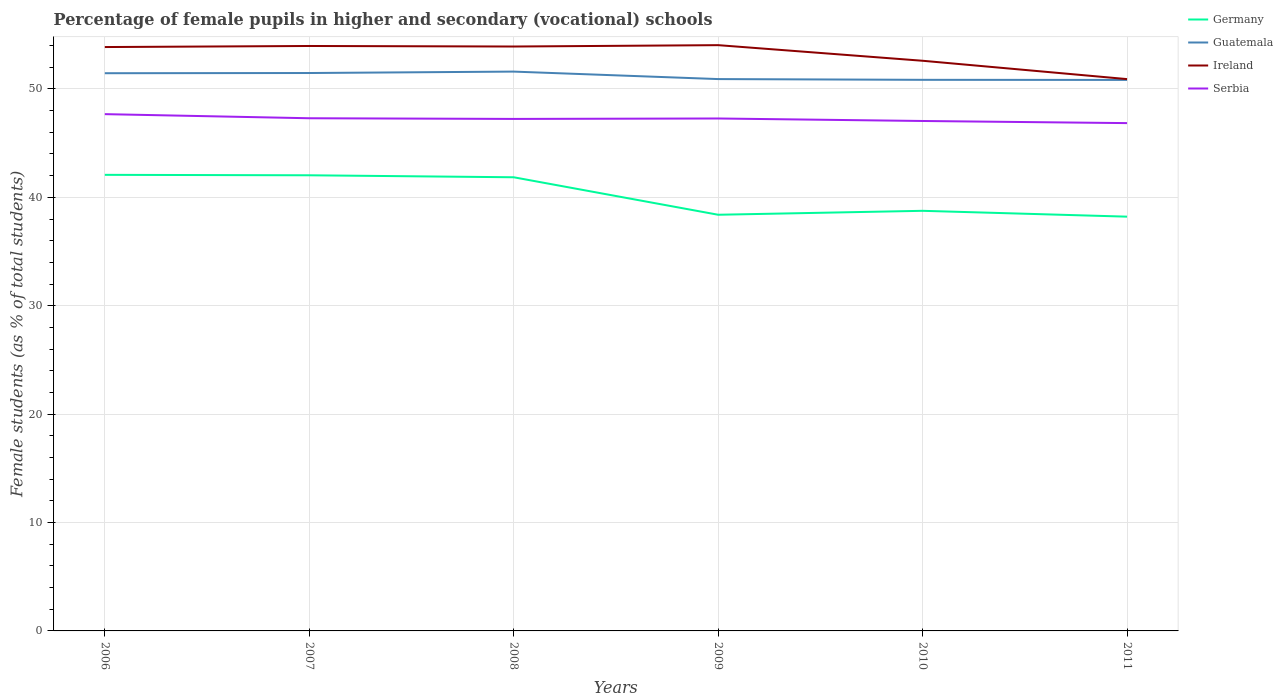Across all years, what is the maximum percentage of female pupils in higher and secondary schools in Serbia?
Your response must be concise. 46.85. In which year was the percentage of female pupils in higher and secondary schools in Ireland maximum?
Ensure brevity in your answer.  2011. What is the total percentage of female pupils in higher and secondary schools in Ireland in the graph?
Offer a terse response. 1.69. What is the difference between the highest and the second highest percentage of female pupils in higher and secondary schools in Serbia?
Offer a very short reply. 0.83. What is the difference between the highest and the lowest percentage of female pupils in higher and secondary schools in Serbia?
Provide a short and direct response. 4. Is the percentage of female pupils in higher and secondary schools in Ireland strictly greater than the percentage of female pupils in higher and secondary schools in Germany over the years?
Your answer should be compact. No. Does the graph contain any zero values?
Keep it short and to the point. No. How are the legend labels stacked?
Your answer should be compact. Vertical. What is the title of the graph?
Offer a very short reply. Percentage of female pupils in higher and secondary (vocational) schools. What is the label or title of the Y-axis?
Your answer should be compact. Female students (as % of total students). What is the Female students (as % of total students) in Germany in 2006?
Give a very brief answer. 42.08. What is the Female students (as % of total students) in Guatemala in 2006?
Make the answer very short. 51.45. What is the Female students (as % of total students) of Ireland in 2006?
Make the answer very short. 53.87. What is the Female students (as % of total students) of Serbia in 2006?
Your response must be concise. 47.68. What is the Female students (as % of total students) of Germany in 2007?
Provide a succinct answer. 42.04. What is the Female students (as % of total students) of Guatemala in 2007?
Provide a succinct answer. 51.47. What is the Female students (as % of total students) in Ireland in 2007?
Offer a very short reply. 53.97. What is the Female students (as % of total students) of Serbia in 2007?
Provide a succinct answer. 47.3. What is the Female students (as % of total students) in Germany in 2008?
Keep it short and to the point. 41.85. What is the Female students (as % of total students) of Guatemala in 2008?
Offer a terse response. 51.6. What is the Female students (as % of total students) of Ireland in 2008?
Make the answer very short. 53.92. What is the Female students (as % of total students) of Serbia in 2008?
Make the answer very short. 47.24. What is the Female students (as % of total students) of Germany in 2009?
Provide a short and direct response. 38.39. What is the Female students (as % of total students) in Guatemala in 2009?
Keep it short and to the point. 50.91. What is the Female students (as % of total students) in Ireland in 2009?
Give a very brief answer. 54.04. What is the Female students (as % of total students) of Serbia in 2009?
Ensure brevity in your answer.  47.28. What is the Female students (as % of total students) in Germany in 2010?
Provide a short and direct response. 38.76. What is the Female students (as % of total students) in Guatemala in 2010?
Provide a short and direct response. 50.84. What is the Female students (as % of total students) in Ireland in 2010?
Give a very brief answer. 52.6. What is the Female students (as % of total students) of Serbia in 2010?
Your answer should be very brief. 47.05. What is the Female students (as % of total students) of Germany in 2011?
Your response must be concise. 38.22. What is the Female students (as % of total students) of Guatemala in 2011?
Ensure brevity in your answer.  50.83. What is the Female students (as % of total students) of Ireland in 2011?
Offer a terse response. 50.91. What is the Female students (as % of total students) in Serbia in 2011?
Offer a very short reply. 46.85. Across all years, what is the maximum Female students (as % of total students) of Germany?
Offer a very short reply. 42.08. Across all years, what is the maximum Female students (as % of total students) in Guatemala?
Make the answer very short. 51.6. Across all years, what is the maximum Female students (as % of total students) in Ireland?
Provide a succinct answer. 54.04. Across all years, what is the maximum Female students (as % of total students) of Serbia?
Provide a succinct answer. 47.68. Across all years, what is the minimum Female students (as % of total students) in Germany?
Your answer should be compact. 38.22. Across all years, what is the minimum Female students (as % of total students) in Guatemala?
Make the answer very short. 50.83. Across all years, what is the minimum Female students (as % of total students) of Ireland?
Give a very brief answer. 50.91. Across all years, what is the minimum Female students (as % of total students) of Serbia?
Give a very brief answer. 46.85. What is the total Female students (as % of total students) in Germany in the graph?
Give a very brief answer. 241.34. What is the total Female students (as % of total students) of Guatemala in the graph?
Provide a succinct answer. 307.11. What is the total Female students (as % of total students) of Ireland in the graph?
Your answer should be very brief. 319.3. What is the total Female students (as % of total students) in Serbia in the graph?
Keep it short and to the point. 283.38. What is the difference between the Female students (as % of total students) of Germany in 2006 and that in 2007?
Keep it short and to the point. 0.04. What is the difference between the Female students (as % of total students) in Guatemala in 2006 and that in 2007?
Keep it short and to the point. -0.02. What is the difference between the Female students (as % of total students) in Ireland in 2006 and that in 2007?
Your response must be concise. -0.1. What is the difference between the Female students (as % of total students) in Serbia in 2006 and that in 2007?
Offer a terse response. 0.38. What is the difference between the Female students (as % of total students) of Germany in 2006 and that in 2008?
Your answer should be compact. 0.22. What is the difference between the Female students (as % of total students) of Guatemala in 2006 and that in 2008?
Your answer should be very brief. -0.15. What is the difference between the Female students (as % of total students) of Ireland in 2006 and that in 2008?
Your answer should be compact. -0.05. What is the difference between the Female students (as % of total students) of Serbia in 2006 and that in 2008?
Provide a short and direct response. 0.44. What is the difference between the Female students (as % of total students) in Germany in 2006 and that in 2009?
Ensure brevity in your answer.  3.68. What is the difference between the Female students (as % of total students) in Guatemala in 2006 and that in 2009?
Your answer should be compact. 0.54. What is the difference between the Female students (as % of total students) in Ireland in 2006 and that in 2009?
Provide a succinct answer. -0.17. What is the difference between the Female students (as % of total students) of Serbia in 2006 and that in 2009?
Provide a succinct answer. 0.4. What is the difference between the Female students (as % of total students) in Germany in 2006 and that in 2010?
Offer a very short reply. 3.32. What is the difference between the Female students (as % of total students) in Guatemala in 2006 and that in 2010?
Make the answer very short. 0.61. What is the difference between the Female students (as % of total students) in Ireland in 2006 and that in 2010?
Ensure brevity in your answer.  1.27. What is the difference between the Female students (as % of total students) of Serbia in 2006 and that in 2010?
Provide a succinct answer. 0.63. What is the difference between the Female students (as % of total students) in Germany in 2006 and that in 2011?
Provide a succinct answer. 3.86. What is the difference between the Female students (as % of total students) in Guatemala in 2006 and that in 2011?
Offer a very short reply. 0.62. What is the difference between the Female students (as % of total students) of Ireland in 2006 and that in 2011?
Keep it short and to the point. 2.96. What is the difference between the Female students (as % of total students) of Serbia in 2006 and that in 2011?
Offer a terse response. 0.83. What is the difference between the Female students (as % of total students) of Germany in 2007 and that in 2008?
Offer a very short reply. 0.18. What is the difference between the Female students (as % of total students) of Guatemala in 2007 and that in 2008?
Give a very brief answer. -0.13. What is the difference between the Female students (as % of total students) in Ireland in 2007 and that in 2008?
Ensure brevity in your answer.  0.05. What is the difference between the Female students (as % of total students) of Serbia in 2007 and that in 2008?
Keep it short and to the point. 0.06. What is the difference between the Female students (as % of total students) of Germany in 2007 and that in 2009?
Provide a short and direct response. 3.64. What is the difference between the Female students (as % of total students) of Guatemala in 2007 and that in 2009?
Provide a short and direct response. 0.56. What is the difference between the Female students (as % of total students) in Ireland in 2007 and that in 2009?
Give a very brief answer. -0.08. What is the difference between the Female students (as % of total students) in Serbia in 2007 and that in 2009?
Your response must be concise. 0.02. What is the difference between the Female students (as % of total students) of Germany in 2007 and that in 2010?
Give a very brief answer. 3.28. What is the difference between the Female students (as % of total students) of Guatemala in 2007 and that in 2010?
Give a very brief answer. 0.63. What is the difference between the Female students (as % of total students) of Ireland in 2007 and that in 2010?
Provide a short and direct response. 1.36. What is the difference between the Female students (as % of total students) of Serbia in 2007 and that in 2010?
Provide a succinct answer. 0.25. What is the difference between the Female students (as % of total students) in Germany in 2007 and that in 2011?
Your answer should be compact. 3.82. What is the difference between the Female students (as % of total students) in Guatemala in 2007 and that in 2011?
Offer a terse response. 0.64. What is the difference between the Female students (as % of total students) of Ireland in 2007 and that in 2011?
Offer a terse response. 3.06. What is the difference between the Female students (as % of total students) of Serbia in 2007 and that in 2011?
Ensure brevity in your answer.  0.45. What is the difference between the Female students (as % of total students) in Germany in 2008 and that in 2009?
Your response must be concise. 3.46. What is the difference between the Female students (as % of total students) in Guatemala in 2008 and that in 2009?
Offer a terse response. 0.69. What is the difference between the Female students (as % of total students) of Ireland in 2008 and that in 2009?
Keep it short and to the point. -0.13. What is the difference between the Female students (as % of total students) in Serbia in 2008 and that in 2009?
Your response must be concise. -0.04. What is the difference between the Female students (as % of total students) in Germany in 2008 and that in 2010?
Give a very brief answer. 3.09. What is the difference between the Female students (as % of total students) in Guatemala in 2008 and that in 2010?
Provide a succinct answer. 0.76. What is the difference between the Female students (as % of total students) in Ireland in 2008 and that in 2010?
Offer a terse response. 1.31. What is the difference between the Female students (as % of total students) in Serbia in 2008 and that in 2010?
Provide a succinct answer. 0.19. What is the difference between the Female students (as % of total students) of Germany in 2008 and that in 2011?
Provide a short and direct response. 3.63. What is the difference between the Female students (as % of total students) of Guatemala in 2008 and that in 2011?
Make the answer very short. 0.77. What is the difference between the Female students (as % of total students) of Ireland in 2008 and that in 2011?
Provide a succinct answer. 3.01. What is the difference between the Female students (as % of total students) of Serbia in 2008 and that in 2011?
Offer a terse response. 0.39. What is the difference between the Female students (as % of total students) of Germany in 2009 and that in 2010?
Your response must be concise. -0.36. What is the difference between the Female students (as % of total students) in Guatemala in 2009 and that in 2010?
Offer a terse response. 0.07. What is the difference between the Female students (as % of total students) of Ireland in 2009 and that in 2010?
Make the answer very short. 1.44. What is the difference between the Female students (as % of total students) in Serbia in 2009 and that in 2010?
Offer a terse response. 0.23. What is the difference between the Female students (as % of total students) of Germany in 2009 and that in 2011?
Keep it short and to the point. 0.17. What is the difference between the Female students (as % of total students) of Guatemala in 2009 and that in 2011?
Provide a succinct answer. 0.08. What is the difference between the Female students (as % of total students) in Ireland in 2009 and that in 2011?
Give a very brief answer. 3.13. What is the difference between the Female students (as % of total students) of Serbia in 2009 and that in 2011?
Your response must be concise. 0.43. What is the difference between the Female students (as % of total students) in Germany in 2010 and that in 2011?
Keep it short and to the point. 0.54. What is the difference between the Female students (as % of total students) of Guatemala in 2010 and that in 2011?
Make the answer very short. 0.01. What is the difference between the Female students (as % of total students) of Ireland in 2010 and that in 2011?
Your answer should be compact. 1.69. What is the difference between the Female students (as % of total students) in Serbia in 2010 and that in 2011?
Your response must be concise. 0.2. What is the difference between the Female students (as % of total students) in Germany in 2006 and the Female students (as % of total students) in Guatemala in 2007?
Your response must be concise. -9.39. What is the difference between the Female students (as % of total students) in Germany in 2006 and the Female students (as % of total students) in Ireland in 2007?
Make the answer very short. -11.89. What is the difference between the Female students (as % of total students) in Germany in 2006 and the Female students (as % of total students) in Serbia in 2007?
Your response must be concise. -5.22. What is the difference between the Female students (as % of total students) in Guatemala in 2006 and the Female students (as % of total students) in Ireland in 2007?
Offer a very short reply. -2.51. What is the difference between the Female students (as % of total students) in Guatemala in 2006 and the Female students (as % of total students) in Serbia in 2007?
Your answer should be compact. 4.15. What is the difference between the Female students (as % of total students) of Ireland in 2006 and the Female students (as % of total students) of Serbia in 2007?
Offer a terse response. 6.57. What is the difference between the Female students (as % of total students) of Germany in 2006 and the Female students (as % of total students) of Guatemala in 2008?
Ensure brevity in your answer.  -9.52. What is the difference between the Female students (as % of total students) of Germany in 2006 and the Female students (as % of total students) of Ireland in 2008?
Your response must be concise. -11.84. What is the difference between the Female students (as % of total students) in Germany in 2006 and the Female students (as % of total students) in Serbia in 2008?
Offer a terse response. -5.16. What is the difference between the Female students (as % of total students) in Guatemala in 2006 and the Female students (as % of total students) in Ireland in 2008?
Provide a short and direct response. -2.46. What is the difference between the Female students (as % of total students) of Guatemala in 2006 and the Female students (as % of total students) of Serbia in 2008?
Offer a terse response. 4.22. What is the difference between the Female students (as % of total students) of Ireland in 2006 and the Female students (as % of total students) of Serbia in 2008?
Ensure brevity in your answer.  6.63. What is the difference between the Female students (as % of total students) in Germany in 2006 and the Female students (as % of total students) in Guatemala in 2009?
Offer a terse response. -8.83. What is the difference between the Female students (as % of total students) of Germany in 2006 and the Female students (as % of total students) of Ireland in 2009?
Your answer should be very brief. -11.96. What is the difference between the Female students (as % of total students) of Germany in 2006 and the Female students (as % of total students) of Serbia in 2009?
Give a very brief answer. -5.2. What is the difference between the Female students (as % of total students) of Guatemala in 2006 and the Female students (as % of total students) of Ireland in 2009?
Your response must be concise. -2.59. What is the difference between the Female students (as % of total students) of Guatemala in 2006 and the Female students (as % of total students) of Serbia in 2009?
Ensure brevity in your answer.  4.18. What is the difference between the Female students (as % of total students) of Ireland in 2006 and the Female students (as % of total students) of Serbia in 2009?
Ensure brevity in your answer.  6.59. What is the difference between the Female students (as % of total students) of Germany in 2006 and the Female students (as % of total students) of Guatemala in 2010?
Keep it short and to the point. -8.77. What is the difference between the Female students (as % of total students) in Germany in 2006 and the Female students (as % of total students) in Ireland in 2010?
Offer a terse response. -10.52. What is the difference between the Female students (as % of total students) of Germany in 2006 and the Female students (as % of total students) of Serbia in 2010?
Your response must be concise. -4.97. What is the difference between the Female students (as % of total students) of Guatemala in 2006 and the Female students (as % of total students) of Ireland in 2010?
Offer a very short reply. -1.15. What is the difference between the Female students (as % of total students) in Guatemala in 2006 and the Female students (as % of total students) in Serbia in 2010?
Give a very brief answer. 4.41. What is the difference between the Female students (as % of total students) of Ireland in 2006 and the Female students (as % of total students) of Serbia in 2010?
Keep it short and to the point. 6.82. What is the difference between the Female students (as % of total students) of Germany in 2006 and the Female students (as % of total students) of Guatemala in 2011?
Keep it short and to the point. -8.76. What is the difference between the Female students (as % of total students) of Germany in 2006 and the Female students (as % of total students) of Ireland in 2011?
Offer a terse response. -8.83. What is the difference between the Female students (as % of total students) in Germany in 2006 and the Female students (as % of total students) in Serbia in 2011?
Ensure brevity in your answer.  -4.77. What is the difference between the Female students (as % of total students) of Guatemala in 2006 and the Female students (as % of total students) of Ireland in 2011?
Provide a short and direct response. 0.54. What is the difference between the Female students (as % of total students) of Guatemala in 2006 and the Female students (as % of total students) of Serbia in 2011?
Your answer should be very brief. 4.6. What is the difference between the Female students (as % of total students) of Ireland in 2006 and the Female students (as % of total students) of Serbia in 2011?
Your response must be concise. 7.02. What is the difference between the Female students (as % of total students) of Germany in 2007 and the Female students (as % of total students) of Guatemala in 2008?
Give a very brief answer. -9.57. What is the difference between the Female students (as % of total students) of Germany in 2007 and the Female students (as % of total students) of Ireland in 2008?
Your response must be concise. -11.88. What is the difference between the Female students (as % of total students) in Germany in 2007 and the Female students (as % of total students) in Serbia in 2008?
Provide a short and direct response. -5.2. What is the difference between the Female students (as % of total students) in Guatemala in 2007 and the Female students (as % of total students) in Ireland in 2008?
Keep it short and to the point. -2.45. What is the difference between the Female students (as % of total students) of Guatemala in 2007 and the Female students (as % of total students) of Serbia in 2008?
Your answer should be compact. 4.23. What is the difference between the Female students (as % of total students) in Ireland in 2007 and the Female students (as % of total students) in Serbia in 2008?
Your answer should be very brief. 6.73. What is the difference between the Female students (as % of total students) in Germany in 2007 and the Female students (as % of total students) in Guatemala in 2009?
Make the answer very short. -8.88. What is the difference between the Female students (as % of total students) in Germany in 2007 and the Female students (as % of total students) in Ireland in 2009?
Provide a succinct answer. -12.01. What is the difference between the Female students (as % of total students) of Germany in 2007 and the Female students (as % of total students) of Serbia in 2009?
Provide a short and direct response. -5.24. What is the difference between the Female students (as % of total students) of Guatemala in 2007 and the Female students (as % of total students) of Ireland in 2009?
Your answer should be very brief. -2.57. What is the difference between the Female students (as % of total students) in Guatemala in 2007 and the Female students (as % of total students) in Serbia in 2009?
Keep it short and to the point. 4.19. What is the difference between the Female students (as % of total students) of Ireland in 2007 and the Female students (as % of total students) of Serbia in 2009?
Your answer should be very brief. 6.69. What is the difference between the Female students (as % of total students) of Germany in 2007 and the Female students (as % of total students) of Guatemala in 2010?
Your answer should be compact. -8.81. What is the difference between the Female students (as % of total students) in Germany in 2007 and the Female students (as % of total students) in Ireland in 2010?
Your response must be concise. -10.57. What is the difference between the Female students (as % of total students) in Germany in 2007 and the Female students (as % of total students) in Serbia in 2010?
Provide a short and direct response. -5.01. What is the difference between the Female students (as % of total students) in Guatemala in 2007 and the Female students (as % of total students) in Ireland in 2010?
Your response must be concise. -1.13. What is the difference between the Female students (as % of total students) in Guatemala in 2007 and the Female students (as % of total students) in Serbia in 2010?
Make the answer very short. 4.42. What is the difference between the Female students (as % of total students) in Ireland in 2007 and the Female students (as % of total students) in Serbia in 2010?
Offer a very short reply. 6.92. What is the difference between the Female students (as % of total students) in Germany in 2007 and the Female students (as % of total students) in Guatemala in 2011?
Your answer should be very brief. -8.8. What is the difference between the Female students (as % of total students) in Germany in 2007 and the Female students (as % of total students) in Ireland in 2011?
Give a very brief answer. -8.87. What is the difference between the Female students (as % of total students) of Germany in 2007 and the Female students (as % of total students) of Serbia in 2011?
Your answer should be compact. -4.81. What is the difference between the Female students (as % of total students) of Guatemala in 2007 and the Female students (as % of total students) of Ireland in 2011?
Keep it short and to the point. 0.56. What is the difference between the Female students (as % of total students) in Guatemala in 2007 and the Female students (as % of total students) in Serbia in 2011?
Offer a terse response. 4.62. What is the difference between the Female students (as % of total students) in Ireland in 2007 and the Female students (as % of total students) in Serbia in 2011?
Provide a short and direct response. 7.12. What is the difference between the Female students (as % of total students) in Germany in 2008 and the Female students (as % of total students) in Guatemala in 2009?
Offer a very short reply. -9.06. What is the difference between the Female students (as % of total students) in Germany in 2008 and the Female students (as % of total students) in Ireland in 2009?
Give a very brief answer. -12.19. What is the difference between the Female students (as % of total students) in Germany in 2008 and the Female students (as % of total students) in Serbia in 2009?
Provide a succinct answer. -5.42. What is the difference between the Female students (as % of total students) of Guatemala in 2008 and the Female students (as % of total students) of Ireland in 2009?
Offer a terse response. -2.44. What is the difference between the Female students (as % of total students) of Guatemala in 2008 and the Female students (as % of total students) of Serbia in 2009?
Make the answer very short. 4.32. What is the difference between the Female students (as % of total students) of Ireland in 2008 and the Female students (as % of total students) of Serbia in 2009?
Your answer should be very brief. 6.64. What is the difference between the Female students (as % of total students) of Germany in 2008 and the Female students (as % of total students) of Guatemala in 2010?
Give a very brief answer. -8.99. What is the difference between the Female students (as % of total students) of Germany in 2008 and the Female students (as % of total students) of Ireland in 2010?
Provide a succinct answer. -10.75. What is the difference between the Female students (as % of total students) of Germany in 2008 and the Female students (as % of total students) of Serbia in 2010?
Ensure brevity in your answer.  -5.19. What is the difference between the Female students (as % of total students) of Guatemala in 2008 and the Female students (as % of total students) of Serbia in 2010?
Make the answer very short. 4.56. What is the difference between the Female students (as % of total students) in Ireland in 2008 and the Female students (as % of total students) in Serbia in 2010?
Ensure brevity in your answer.  6.87. What is the difference between the Female students (as % of total students) of Germany in 2008 and the Female students (as % of total students) of Guatemala in 2011?
Make the answer very short. -8.98. What is the difference between the Female students (as % of total students) of Germany in 2008 and the Female students (as % of total students) of Ireland in 2011?
Provide a succinct answer. -9.06. What is the difference between the Female students (as % of total students) in Germany in 2008 and the Female students (as % of total students) in Serbia in 2011?
Provide a succinct answer. -5. What is the difference between the Female students (as % of total students) of Guatemala in 2008 and the Female students (as % of total students) of Ireland in 2011?
Make the answer very short. 0.69. What is the difference between the Female students (as % of total students) in Guatemala in 2008 and the Female students (as % of total students) in Serbia in 2011?
Ensure brevity in your answer.  4.75. What is the difference between the Female students (as % of total students) of Ireland in 2008 and the Female students (as % of total students) of Serbia in 2011?
Ensure brevity in your answer.  7.07. What is the difference between the Female students (as % of total students) of Germany in 2009 and the Female students (as % of total students) of Guatemala in 2010?
Offer a terse response. -12.45. What is the difference between the Female students (as % of total students) of Germany in 2009 and the Female students (as % of total students) of Ireland in 2010?
Keep it short and to the point. -14.21. What is the difference between the Female students (as % of total students) in Germany in 2009 and the Female students (as % of total students) in Serbia in 2010?
Your answer should be compact. -8.65. What is the difference between the Female students (as % of total students) in Guatemala in 2009 and the Female students (as % of total students) in Ireland in 2010?
Offer a very short reply. -1.69. What is the difference between the Female students (as % of total students) of Guatemala in 2009 and the Female students (as % of total students) of Serbia in 2010?
Your answer should be compact. 3.87. What is the difference between the Female students (as % of total students) in Ireland in 2009 and the Female students (as % of total students) in Serbia in 2010?
Your answer should be very brief. 7. What is the difference between the Female students (as % of total students) of Germany in 2009 and the Female students (as % of total students) of Guatemala in 2011?
Offer a very short reply. -12.44. What is the difference between the Female students (as % of total students) of Germany in 2009 and the Female students (as % of total students) of Ireland in 2011?
Your response must be concise. -12.51. What is the difference between the Female students (as % of total students) in Germany in 2009 and the Female students (as % of total students) in Serbia in 2011?
Provide a succinct answer. -8.46. What is the difference between the Female students (as % of total students) in Guatemala in 2009 and the Female students (as % of total students) in Ireland in 2011?
Give a very brief answer. 0. What is the difference between the Female students (as % of total students) in Guatemala in 2009 and the Female students (as % of total students) in Serbia in 2011?
Offer a very short reply. 4.06. What is the difference between the Female students (as % of total students) of Ireland in 2009 and the Female students (as % of total students) of Serbia in 2011?
Provide a succinct answer. 7.19. What is the difference between the Female students (as % of total students) in Germany in 2010 and the Female students (as % of total students) in Guatemala in 2011?
Your response must be concise. -12.07. What is the difference between the Female students (as % of total students) of Germany in 2010 and the Female students (as % of total students) of Ireland in 2011?
Your answer should be very brief. -12.15. What is the difference between the Female students (as % of total students) in Germany in 2010 and the Female students (as % of total students) in Serbia in 2011?
Your answer should be very brief. -8.09. What is the difference between the Female students (as % of total students) of Guatemala in 2010 and the Female students (as % of total students) of Ireland in 2011?
Your response must be concise. -0.07. What is the difference between the Female students (as % of total students) in Guatemala in 2010 and the Female students (as % of total students) in Serbia in 2011?
Ensure brevity in your answer.  3.99. What is the difference between the Female students (as % of total students) of Ireland in 2010 and the Female students (as % of total students) of Serbia in 2011?
Give a very brief answer. 5.75. What is the average Female students (as % of total students) in Germany per year?
Keep it short and to the point. 40.22. What is the average Female students (as % of total students) of Guatemala per year?
Your answer should be compact. 51.19. What is the average Female students (as % of total students) in Ireland per year?
Provide a short and direct response. 53.22. What is the average Female students (as % of total students) in Serbia per year?
Your answer should be compact. 47.23. In the year 2006, what is the difference between the Female students (as % of total students) in Germany and Female students (as % of total students) in Guatemala?
Offer a very short reply. -9.38. In the year 2006, what is the difference between the Female students (as % of total students) in Germany and Female students (as % of total students) in Ireland?
Your response must be concise. -11.79. In the year 2006, what is the difference between the Female students (as % of total students) in Germany and Female students (as % of total students) in Serbia?
Your response must be concise. -5.6. In the year 2006, what is the difference between the Female students (as % of total students) of Guatemala and Female students (as % of total students) of Ireland?
Your response must be concise. -2.41. In the year 2006, what is the difference between the Female students (as % of total students) of Guatemala and Female students (as % of total students) of Serbia?
Make the answer very short. 3.78. In the year 2006, what is the difference between the Female students (as % of total students) in Ireland and Female students (as % of total students) in Serbia?
Offer a terse response. 6.19. In the year 2007, what is the difference between the Female students (as % of total students) of Germany and Female students (as % of total students) of Guatemala?
Offer a very short reply. -9.43. In the year 2007, what is the difference between the Female students (as % of total students) in Germany and Female students (as % of total students) in Ireland?
Your answer should be very brief. -11.93. In the year 2007, what is the difference between the Female students (as % of total students) of Germany and Female students (as % of total students) of Serbia?
Your response must be concise. -5.26. In the year 2007, what is the difference between the Female students (as % of total students) in Guatemala and Female students (as % of total students) in Ireland?
Make the answer very short. -2.5. In the year 2007, what is the difference between the Female students (as % of total students) of Guatemala and Female students (as % of total students) of Serbia?
Provide a succinct answer. 4.17. In the year 2007, what is the difference between the Female students (as % of total students) of Ireland and Female students (as % of total students) of Serbia?
Ensure brevity in your answer.  6.67. In the year 2008, what is the difference between the Female students (as % of total students) of Germany and Female students (as % of total students) of Guatemala?
Your answer should be very brief. -9.75. In the year 2008, what is the difference between the Female students (as % of total students) of Germany and Female students (as % of total students) of Ireland?
Keep it short and to the point. -12.06. In the year 2008, what is the difference between the Female students (as % of total students) of Germany and Female students (as % of total students) of Serbia?
Ensure brevity in your answer.  -5.38. In the year 2008, what is the difference between the Female students (as % of total students) of Guatemala and Female students (as % of total students) of Ireland?
Make the answer very short. -2.31. In the year 2008, what is the difference between the Female students (as % of total students) of Guatemala and Female students (as % of total students) of Serbia?
Make the answer very short. 4.37. In the year 2008, what is the difference between the Female students (as % of total students) in Ireland and Female students (as % of total students) in Serbia?
Provide a short and direct response. 6.68. In the year 2009, what is the difference between the Female students (as % of total students) in Germany and Female students (as % of total students) in Guatemala?
Your answer should be compact. -12.52. In the year 2009, what is the difference between the Female students (as % of total students) in Germany and Female students (as % of total students) in Ireland?
Provide a succinct answer. -15.65. In the year 2009, what is the difference between the Female students (as % of total students) of Germany and Female students (as % of total students) of Serbia?
Offer a very short reply. -8.88. In the year 2009, what is the difference between the Female students (as % of total students) in Guatemala and Female students (as % of total students) in Ireland?
Your answer should be compact. -3.13. In the year 2009, what is the difference between the Female students (as % of total students) of Guatemala and Female students (as % of total students) of Serbia?
Provide a succinct answer. 3.63. In the year 2009, what is the difference between the Female students (as % of total students) in Ireland and Female students (as % of total students) in Serbia?
Offer a very short reply. 6.76. In the year 2010, what is the difference between the Female students (as % of total students) of Germany and Female students (as % of total students) of Guatemala?
Provide a succinct answer. -12.08. In the year 2010, what is the difference between the Female students (as % of total students) in Germany and Female students (as % of total students) in Ireland?
Your answer should be compact. -13.84. In the year 2010, what is the difference between the Female students (as % of total students) of Germany and Female students (as % of total students) of Serbia?
Ensure brevity in your answer.  -8.29. In the year 2010, what is the difference between the Female students (as % of total students) of Guatemala and Female students (as % of total students) of Ireland?
Your response must be concise. -1.76. In the year 2010, what is the difference between the Female students (as % of total students) in Guatemala and Female students (as % of total students) in Serbia?
Provide a succinct answer. 3.8. In the year 2010, what is the difference between the Female students (as % of total students) of Ireland and Female students (as % of total students) of Serbia?
Offer a very short reply. 5.56. In the year 2011, what is the difference between the Female students (as % of total students) in Germany and Female students (as % of total students) in Guatemala?
Offer a very short reply. -12.61. In the year 2011, what is the difference between the Female students (as % of total students) in Germany and Female students (as % of total students) in Ireland?
Make the answer very short. -12.69. In the year 2011, what is the difference between the Female students (as % of total students) in Germany and Female students (as % of total students) in Serbia?
Provide a succinct answer. -8.63. In the year 2011, what is the difference between the Female students (as % of total students) in Guatemala and Female students (as % of total students) in Ireland?
Provide a short and direct response. -0.08. In the year 2011, what is the difference between the Female students (as % of total students) of Guatemala and Female students (as % of total students) of Serbia?
Make the answer very short. 3.98. In the year 2011, what is the difference between the Female students (as % of total students) of Ireland and Female students (as % of total students) of Serbia?
Make the answer very short. 4.06. What is the ratio of the Female students (as % of total students) in Germany in 2006 to that in 2007?
Make the answer very short. 1. What is the ratio of the Female students (as % of total students) in Ireland in 2006 to that in 2007?
Keep it short and to the point. 1. What is the ratio of the Female students (as % of total students) of Serbia in 2006 to that in 2007?
Offer a terse response. 1.01. What is the ratio of the Female students (as % of total students) of Ireland in 2006 to that in 2008?
Your answer should be very brief. 1. What is the ratio of the Female students (as % of total students) in Serbia in 2006 to that in 2008?
Your response must be concise. 1.01. What is the ratio of the Female students (as % of total students) in Germany in 2006 to that in 2009?
Provide a short and direct response. 1.1. What is the ratio of the Female students (as % of total students) in Guatemala in 2006 to that in 2009?
Your answer should be very brief. 1.01. What is the ratio of the Female students (as % of total students) in Serbia in 2006 to that in 2009?
Your response must be concise. 1.01. What is the ratio of the Female students (as % of total students) in Germany in 2006 to that in 2010?
Give a very brief answer. 1.09. What is the ratio of the Female students (as % of total students) in Guatemala in 2006 to that in 2010?
Your response must be concise. 1.01. What is the ratio of the Female students (as % of total students) in Ireland in 2006 to that in 2010?
Give a very brief answer. 1.02. What is the ratio of the Female students (as % of total students) in Serbia in 2006 to that in 2010?
Keep it short and to the point. 1.01. What is the ratio of the Female students (as % of total students) in Germany in 2006 to that in 2011?
Ensure brevity in your answer.  1.1. What is the ratio of the Female students (as % of total students) in Guatemala in 2006 to that in 2011?
Your answer should be very brief. 1.01. What is the ratio of the Female students (as % of total students) of Ireland in 2006 to that in 2011?
Provide a short and direct response. 1.06. What is the ratio of the Female students (as % of total students) in Serbia in 2006 to that in 2011?
Make the answer very short. 1.02. What is the ratio of the Female students (as % of total students) of Germany in 2007 to that in 2008?
Your answer should be compact. 1. What is the ratio of the Female students (as % of total students) of Ireland in 2007 to that in 2008?
Provide a short and direct response. 1. What is the ratio of the Female students (as % of total students) of Germany in 2007 to that in 2009?
Make the answer very short. 1.09. What is the ratio of the Female students (as % of total students) in Germany in 2007 to that in 2010?
Offer a terse response. 1.08. What is the ratio of the Female students (as % of total students) of Guatemala in 2007 to that in 2010?
Offer a terse response. 1.01. What is the ratio of the Female students (as % of total students) of Ireland in 2007 to that in 2010?
Give a very brief answer. 1.03. What is the ratio of the Female students (as % of total students) in Serbia in 2007 to that in 2010?
Your response must be concise. 1.01. What is the ratio of the Female students (as % of total students) in Germany in 2007 to that in 2011?
Offer a very short reply. 1.1. What is the ratio of the Female students (as % of total students) of Guatemala in 2007 to that in 2011?
Provide a short and direct response. 1.01. What is the ratio of the Female students (as % of total students) of Ireland in 2007 to that in 2011?
Offer a very short reply. 1.06. What is the ratio of the Female students (as % of total students) of Serbia in 2007 to that in 2011?
Ensure brevity in your answer.  1.01. What is the ratio of the Female students (as % of total students) in Germany in 2008 to that in 2009?
Your response must be concise. 1.09. What is the ratio of the Female students (as % of total students) of Guatemala in 2008 to that in 2009?
Your answer should be very brief. 1.01. What is the ratio of the Female students (as % of total students) of Serbia in 2008 to that in 2009?
Give a very brief answer. 1. What is the ratio of the Female students (as % of total students) in Germany in 2008 to that in 2010?
Your answer should be very brief. 1.08. What is the ratio of the Female students (as % of total students) of Guatemala in 2008 to that in 2010?
Make the answer very short. 1.01. What is the ratio of the Female students (as % of total students) of Ireland in 2008 to that in 2010?
Make the answer very short. 1.02. What is the ratio of the Female students (as % of total students) in Germany in 2008 to that in 2011?
Ensure brevity in your answer.  1.1. What is the ratio of the Female students (as % of total students) in Guatemala in 2008 to that in 2011?
Provide a succinct answer. 1.02. What is the ratio of the Female students (as % of total students) of Ireland in 2008 to that in 2011?
Offer a terse response. 1.06. What is the ratio of the Female students (as % of total students) in Serbia in 2008 to that in 2011?
Your answer should be very brief. 1.01. What is the ratio of the Female students (as % of total students) in Germany in 2009 to that in 2010?
Your answer should be compact. 0.99. What is the ratio of the Female students (as % of total students) of Ireland in 2009 to that in 2010?
Your answer should be very brief. 1.03. What is the ratio of the Female students (as % of total students) in Ireland in 2009 to that in 2011?
Your response must be concise. 1.06. What is the ratio of the Female students (as % of total students) in Serbia in 2009 to that in 2011?
Your answer should be compact. 1.01. What is the ratio of the Female students (as % of total students) in Germany in 2010 to that in 2011?
Provide a succinct answer. 1.01. What is the ratio of the Female students (as % of total students) in Guatemala in 2010 to that in 2011?
Your answer should be compact. 1. What is the ratio of the Female students (as % of total students) of Ireland in 2010 to that in 2011?
Provide a short and direct response. 1.03. What is the ratio of the Female students (as % of total students) of Serbia in 2010 to that in 2011?
Your answer should be compact. 1. What is the difference between the highest and the second highest Female students (as % of total students) of Germany?
Make the answer very short. 0.04. What is the difference between the highest and the second highest Female students (as % of total students) in Guatemala?
Offer a very short reply. 0.13. What is the difference between the highest and the second highest Female students (as % of total students) in Ireland?
Provide a short and direct response. 0.08. What is the difference between the highest and the second highest Female students (as % of total students) of Serbia?
Offer a terse response. 0.38. What is the difference between the highest and the lowest Female students (as % of total students) of Germany?
Provide a short and direct response. 3.86. What is the difference between the highest and the lowest Female students (as % of total students) in Guatemala?
Your answer should be compact. 0.77. What is the difference between the highest and the lowest Female students (as % of total students) in Ireland?
Keep it short and to the point. 3.13. What is the difference between the highest and the lowest Female students (as % of total students) in Serbia?
Make the answer very short. 0.83. 